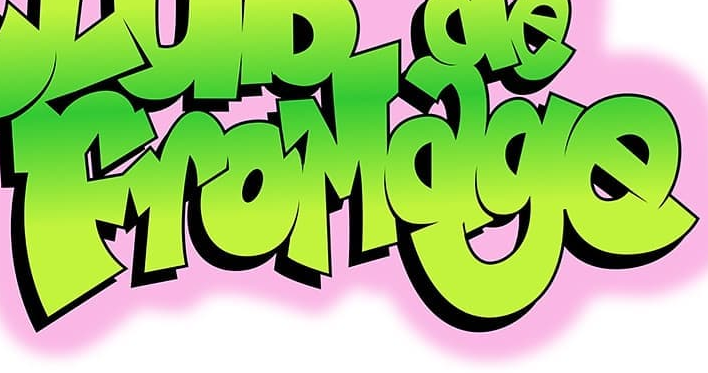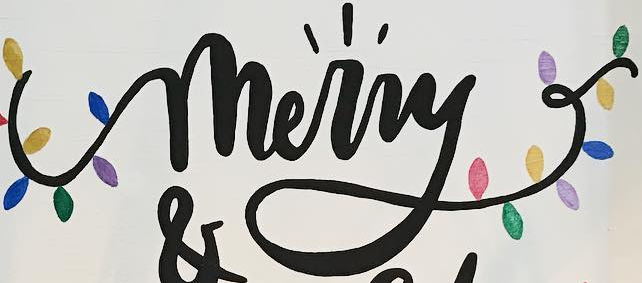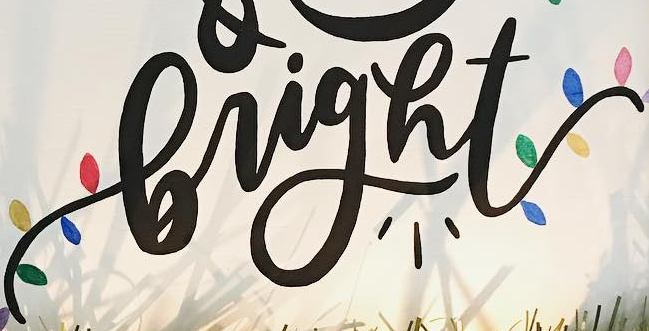What words are shown in these images in order, separated by a semicolon? FroMage; merry; bright 